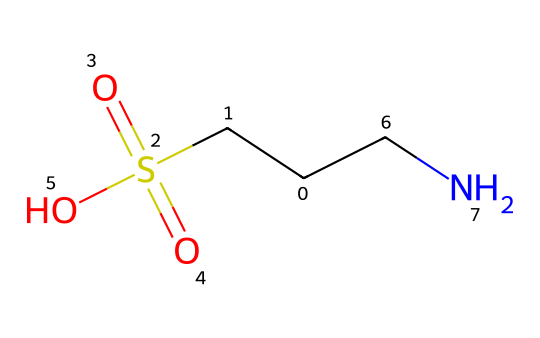What is the molecular formula of taurine? By analyzing the SMILES representation, we can identify the components: there are two carbon atoms (C), seven hydrogen atoms (H), one nitrogen atom (N), and three oxygen atoms (O) from the sulfate group. Thus, the molecular formula sums up to C2H7N1O3S1.
Answer: C2H7NO3S How many hydrogen atoms are in taurine? The SMILES notation clearly indicates the number of hydrogen atoms connected to the carbons and nitrogen. There are a total of seven hydrogen atoms in taurine's structure.
Answer: 7 What functional groups are present in taurine? In the SMILES structure, we observe a sulfonic acid group (−SO3H) and an amine group (−NH2). These are the two main functional groups indicated, which are characteristic of taurine's structure.
Answer: sulfonic acid and amine How does the nitrogen affect taurine's properties? The nitrogen atom in taurine is part of an amine group, which increases the solubility of the molecule in water. This property is essential for its role in various physiological functions and its use in beverages.
Answer: increases solubility What role does taurine play in energy beverages? Taurine is believed to improve mental performance and physical energy, acting as a stimulant, which is why it is commonly added to energy drinks to enhance energy levels and focus.
Answer: stimulant How is taurine different from proteinogenic amino acids? Unlike proteinogenic amino acids that are incorporated into proteins, taurine is a non-proteinogenic amino acid, meaning it does not participate in protein synthesis but plays other vital roles in the body.
Answer: non-proteinogenic What is the primary source of taurine in the diet? Taurine is primarily found in animal-based foods like meat and seafood. It is synthesized in small amounts in the human body, but dietary sources are important for adequate levels.
Answer: animal-based foods 